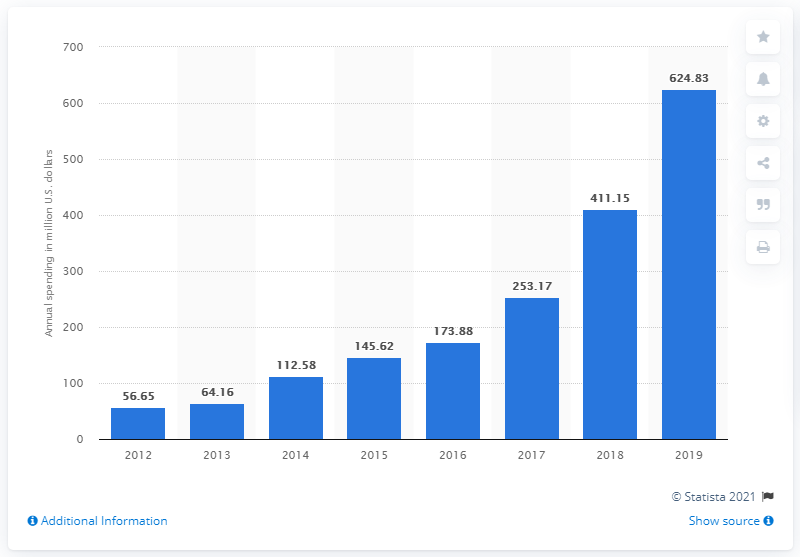Draw attention to some important aspects in this diagram. Square spent 624.83 million dollars on sales and marketing in its most recent year. 